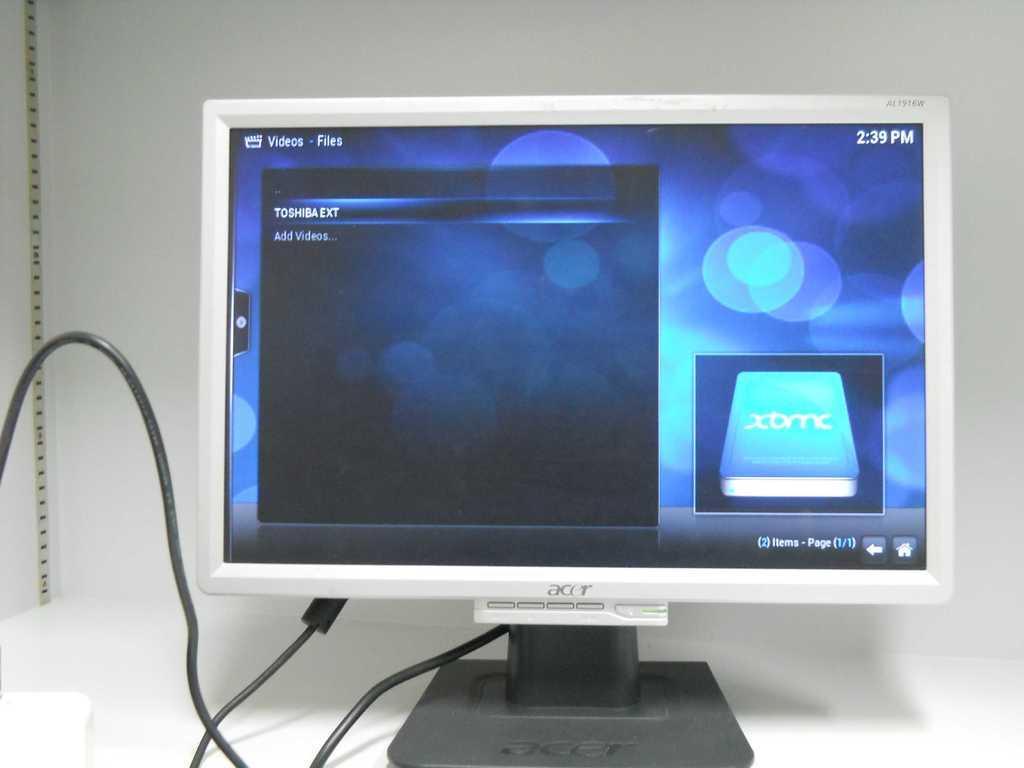Describe this image in one or two sentences. In this image we can see a computer placed on the table. In the background there is a wall. 